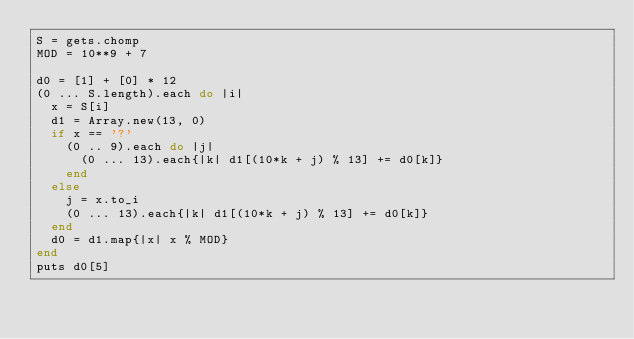Convert code to text. <code><loc_0><loc_0><loc_500><loc_500><_Ruby_>S = gets.chomp
MOD = 10**9 + 7

d0 = [1] + [0] * 12
(0 ... S.length).each do |i|
  x = S[i]
  d1 = Array.new(13, 0)
  if x == '?'
    (0 .. 9).each do |j|
      (0 ... 13).each{|k| d1[(10*k + j) % 13] += d0[k]}
    end
  else
    j = x.to_i
    (0 ... 13).each{|k| d1[(10*k + j) % 13] += d0[k]}
  end
  d0 = d1.map{|x| x % MOD}
end
puts d0[5]</code> 